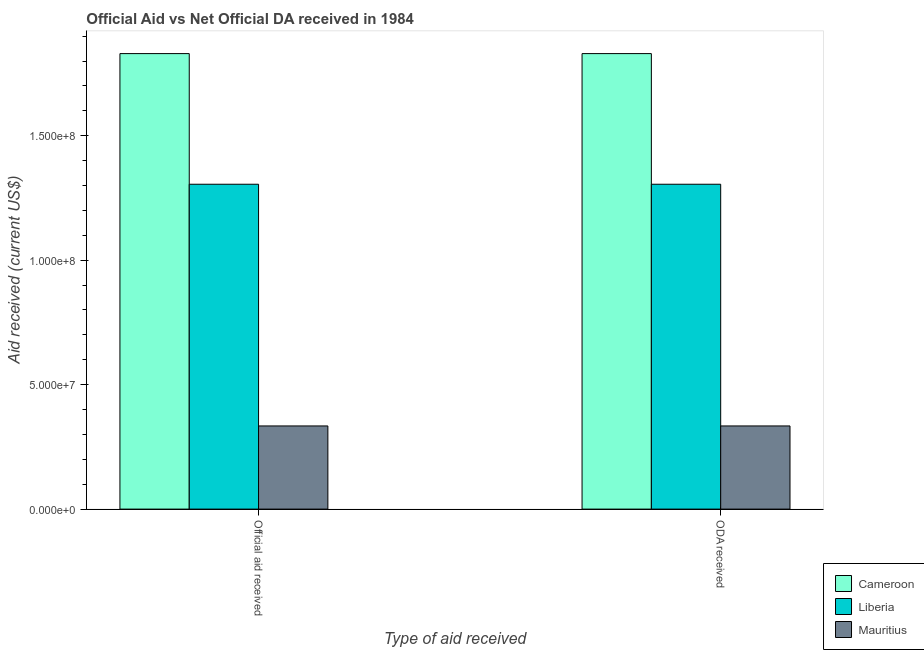How many groups of bars are there?
Your answer should be compact. 2. What is the label of the 1st group of bars from the left?
Make the answer very short. Official aid received. What is the oda received in Liberia?
Provide a short and direct response. 1.31e+08. Across all countries, what is the maximum oda received?
Your response must be concise. 1.83e+08. Across all countries, what is the minimum oda received?
Provide a short and direct response. 3.34e+07. In which country was the official aid received maximum?
Provide a short and direct response. Cameroon. In which country was the oda received minimum?
Give a very brief answer. Mauritius. What is the total official aid received in the graph?
Make the answer very short. 3.47e+08. What is the difference between the oda received in Liberia and that in Cameroon?
Ensure brevity in your answer.  -5.25e+07. What is the difference between the oda received in Mauritius and the official aid received in Cameroon?
Offer a terse response. -1.50e+08. What is the average official aid received per country?
Your answer should be very brief. 1.16e+08. What is the ratio of the oda received in Cameroon to that in Mauritius?
Provide a succinct answer. 5.48. Is the oda received in Cameroon less than that in Mauritius?
Offer a very short reply. No. What does the 2nd bar from the left in ODA received represents?
Offer a terse response. Liberia. What does the 3rd bar from the right in Official aid received represents?
Ensure brevity in your answer.  Cameroon. How many bars are there?
Provide a short and direct response. 6. Are all the bars in the graph horizontal?
Provide a succinct answer. No. What is the difference between two consecutive major ticks on the Y-axis?
Offer a terse response. 5.00e+07. Are the values on the major ticks of Y-axis written in scientific E-notation?
Keep it short and to the point. Yes. Does the graph contain any zero values?
Your answer should be compact. No. Does the graph contain grids?
Keep it short and to the point. No. How are the legend labels stacked?
Your answer should be compact. Vertical. What is the title of the graph?
Provide a short and direct response. Official Aid vs Net Official DA received in 1984 . Does "Solomon Islands" appear as one of the legend labels in the graph?
Provide a short and direct response. No. What is the label or title of the X-axis?
Offer a very short reply. Type of aid received. What is the label or title of the Y-axis?
Give a very brief answer. Aid received (current US$). What is the Aid received (current US$) of Cameroon in Official aid received?
Offer a very short reply. 1.83e+08. What is the Aid received (current US$) of Liberia in Official aid received?
Offer a very short reply. 1.31e+08. What is the Aid received (current US$) in Mauritius in Official aid received?
Ensure brevity in your answer.  3.34e+07. What is the Aid received (current US$) in Cameroon in ODA received?
Keep it short and to the point. 1.83e+08. What is the Aid received (current US$) in Liberia in ODA received?
Provide a short and direct response. 1.31e+08. What is the Aid received (current US$) of Mauritius in ODA received?
Offer a very short reply. 3.34e+07. Across all Type of aid received, what is the maximum Aid received (current US$) of Cameroon?
Provide a short and direct response. 1.83e+08. Across all Type of aid received, what is the maximum Aid received (current US$) in Liberia?
Make the answer very short. 1.31e+08. Across all Type of aid received, what is the maximum Aid received (current US$) in Mauritius?
Your response must be concise. 3.34e+07. Across all Type of aid received, what is the minimum Aid received (current US$) in Cameroon?
Ensure brevity in your answer.  1.83e+08. Across all Type of aid received, what is the minimum Aid received (current US$) of Liberia?
Your response must be concise. 1.31e+08. Across all Type of aid received, what is the minimum Aid received (current US$) in Mauritius?
Give a very brief answer. 3.34e+07. What is the total Aid received (current US$) of Cameroon in the graph?
Provide a short and direct response. 3.66e+08. What is the total Aid received (current US$) in Liberia in the graph?
Provide a short and direct response. 2.61e+08. What is the total Aid received (current US$) in Mauritius in the graph?
Provide a succinct answer. 6.68e+07. What is the difference between the Aid received (current US$) in Cameroon in Official aid received and that in ODA received?
Ensure brevity in your answer.  0. What is the difference between the Aid received (current US$) in Cameroon in Official aid received and the Aid received (current US$) in Liberia in ODA received?
Give a very brief answer. 5.25e+07. What is the difference between the Aid received (current US$) in Cameroon in Official aid received and the Aid received (current US$) in Mauritius in ODA received?
Give a very brief answer. 1.50e+08. What is the difference between the Aid received (current US$) in Liberia in Official aid received and the Aid received (current US$) in Mauritius in ODA received?
Make the answer very short. 9.71e+07. What is the average Aid received (current US$) of Cameroon per Type of aid received?
Your answer should be compact. 1.83e+08. What is the average Aid received (current US$) in Liberia per Type of aid received?
Ensure brevity in your answer.  1.31e+08. What is the average Aid received (current US$) of Mauritius per Type of aid received?
Provide a succinct answer. 3.34e+07. What is the difference between the Aid received (current US$) of Cameroon and Aid received (current US$) of Liberia in Official aid received?
Your response must be concise. 5.25e+07. What is the difference between the Aid received (current US$) of Cameroon and Aid received (current US$) of Mauritius in Official aid received?
Offer a terse response. 1.50e+08. What is the difference between the Aid received (current US$) of Liberia and Aid received (current US$) of Mauritius in Official aid received?
Your response must be concise. 9.71e+07. What is the difference between the Aid received (current US$) in Cameroon and Aid received (current US$) in Liberia in ODA received?
Your answer should be very brief. 5.25e+07. What is the difference between the Aid received (current US$) in Cameroon and Aid received (current US$) in Mauritius in ODA received?
Offer a very short reply. 1.50e+08. What is the difference between the Aid received (current US$) in Liberia and Aid received (current US$) in Mauritius in ODA received?
Your answer should be very brief. 9.71e+07. What is the ratio of the Aid received (current US$) in Cameroon in Official aid received to that in ODA received?
Give a very brief answer. 1. What is the ratio of the Aid received (current US$) in Liberia in Official aid received to that in ODA received?
Offer a very short reply. 1. What is the difference between the highest and the second highest Aid received (current US$) of Liberia?
Your answer should be very brief. 0. What is the difference between the highest and the lowest Aid received (current US$) in Liberia?
Your answer should be compact. 0. 